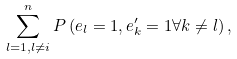<formula> <loc_0><loc_0><loc_500><loc_500>\sum _ { l = 1 , l \ne i } ^ { n } P \left ( e _ { l } = 1 , e _ { k } ^ { \prime } = 1 \forall k \ne l \right ) ,</formula> 